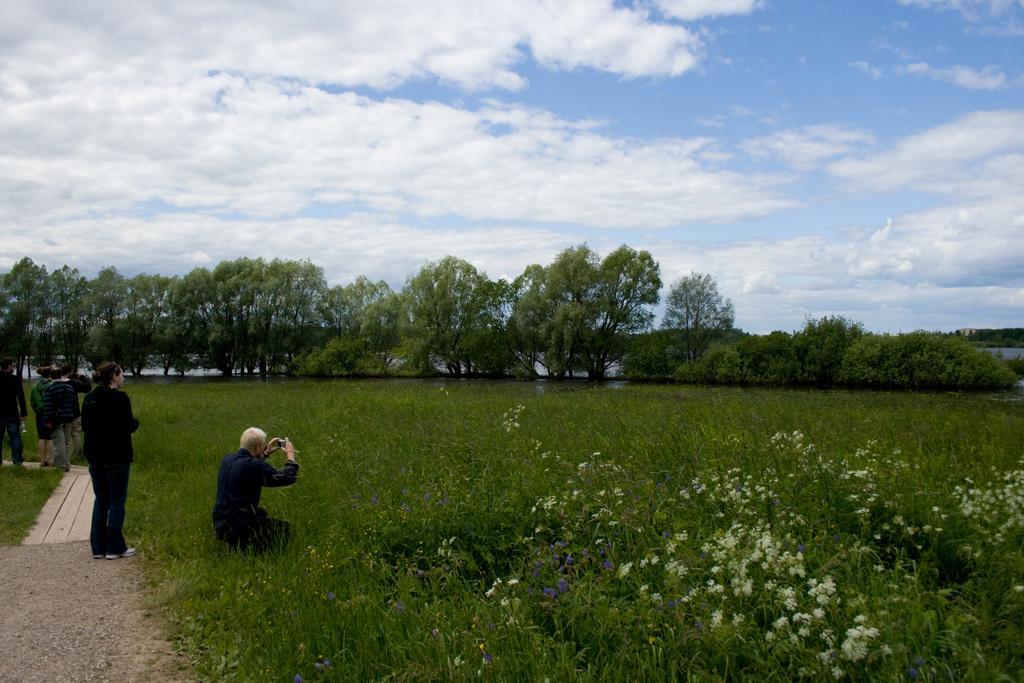How would you summarize this image in a sentence or two? In the image there is a beautiful garden, around the garden there are many trees, the people are standing on the left side and some of them are capturing the photos of the garden, one of the person is sitting in between the garden and taking photos. 